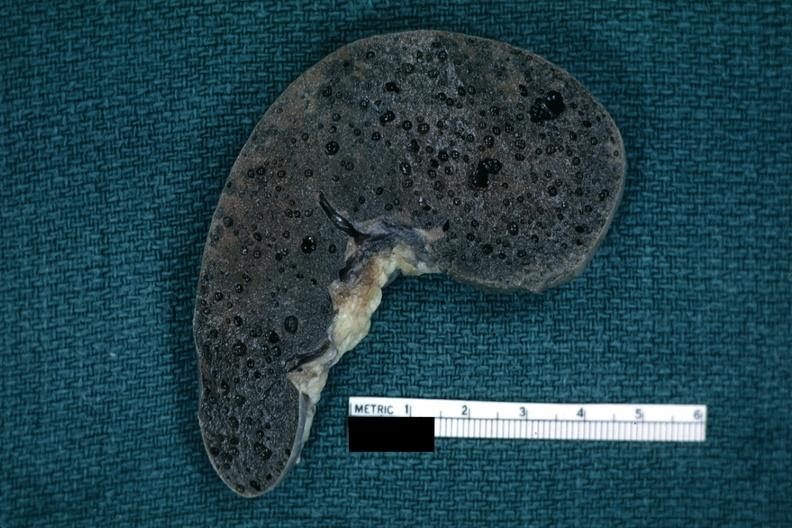what is present?
Answer the question using a single word or phrase. Hematologic 